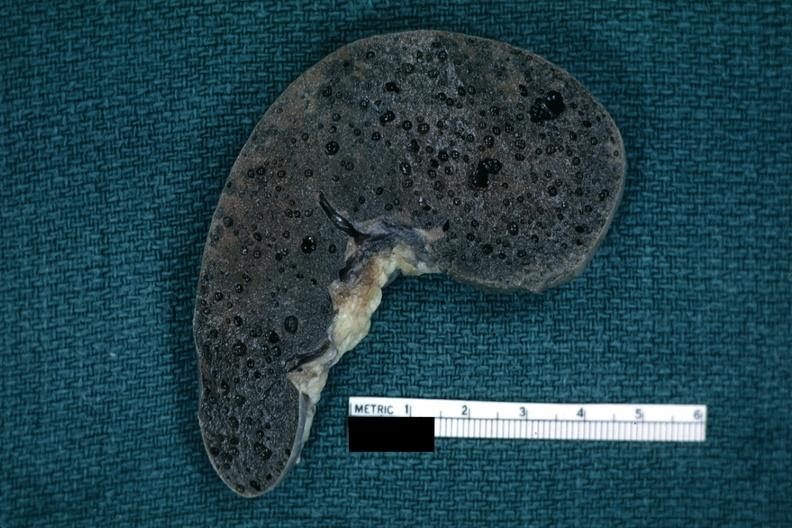what is present?
Answer the question using a single word or phrase. Hematologic 